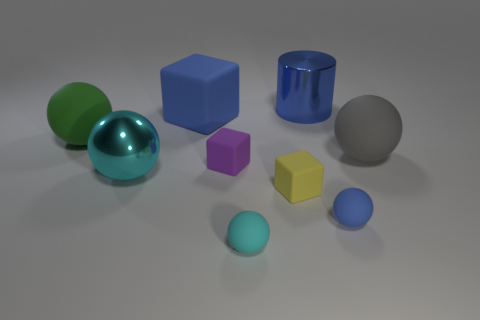Subtract all blue cubes. How many cubes are left? 2 Subtract all tiny yellow rubber cubes. How many cubes are left? 2 Subtract all cylinders. How many objects are left? 8 Add 1 big yellow objects. How many objects exist? 10 Subtract 1 cylinders. How many cylinders are left? 0 Subtract all large matte blocks. Subtract all cyan matte spheres. How many objects are left? 7 Add 5 large blue cylinders. How many large blue cylinders are left? 6 Add 3 small cyan metal objects. How many small cyan metal objects exist? 3 Subtract 0 green blocks. How many objects are left? 9 Subtract all gray cylinders. Subtract all red blocks. How many cylinders are left? 1 